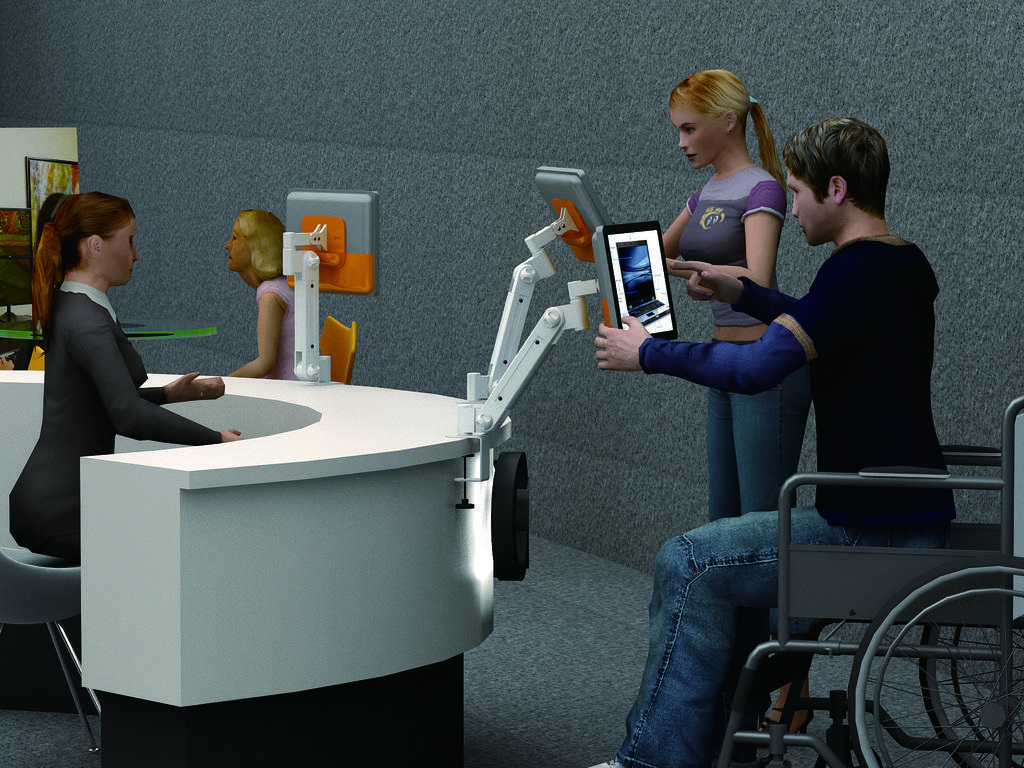Describe this image in one or two sentences. This is an animation picture shows a person sitting on a wheel chair and operating a monitor with his hands and a woman standing and operating a monitor and a woman seated on a chair at a desk. 